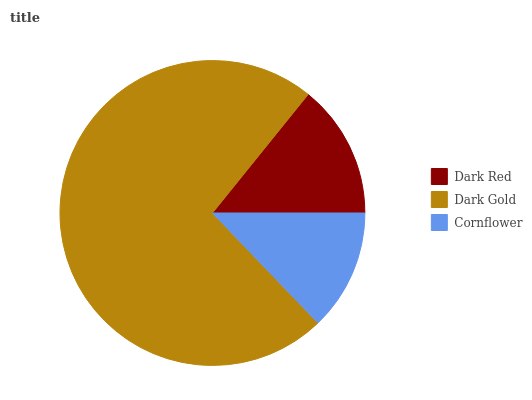Is Cornflower the minimum?
Answer yes or no. Yes. Is Dark Gold the maximum?
Answer yes or no. Yes. Is Dark Gold the minimum?
Answer yes or no. No. Is Cornflower the maximum?
Answer yes or no. No. Is Dark Gold greater than Cornflower?
Answer yes or no. Yes. Is Cornflower less than Dark Gold?
Answer yes or no. Yes. Is Cornflower greater than Dark Gold?
Answer yes or no. No. Is Dark Gold less than Cornflower?
Answer yes or no. No. Is Dark Red the high median?
Answer yes or no. Yes. Is Dark Red the low median?
Answer yes or no. Yes. Is Cornflower the high median?
Answer yes or no. No. Is Dark Gold the low median?
Answer yes or no. No. 